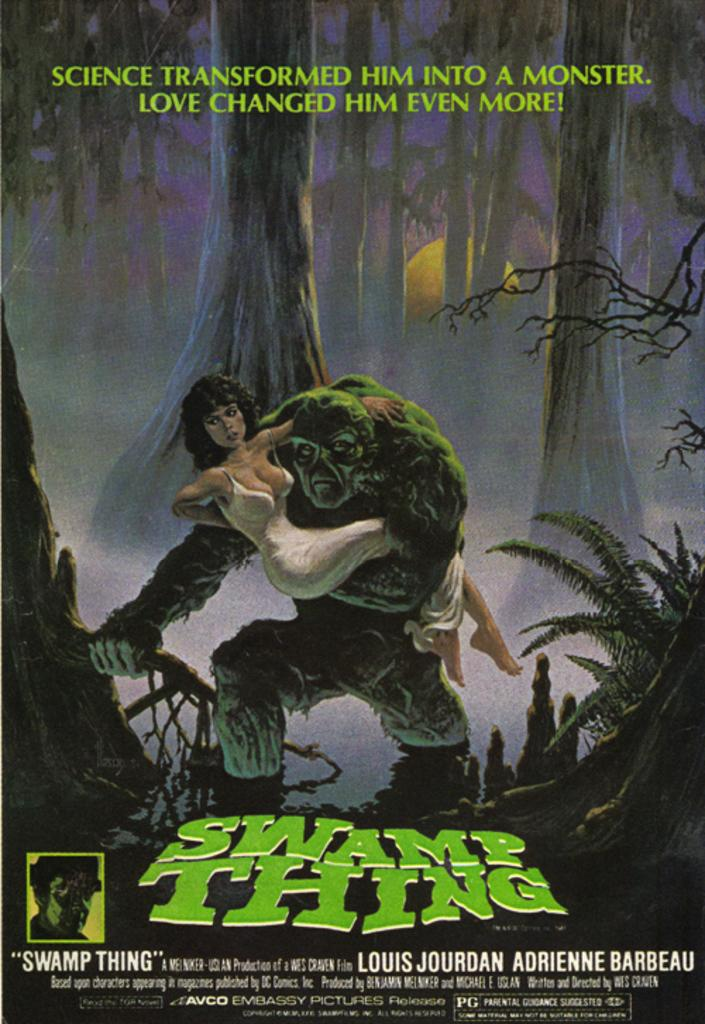Provide a one-sentence caption for the provided image. a poster for Swamp Thing holding a woman in a white dress. 